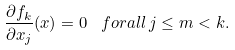<formula> <loc_0><loc_0><loc_500><loc_500>\frac { \partial f _ { k } } { \partial x _ { j } } ( x ) = 0 \, \ f o r a l l \, j \leq m < k .</formula> 